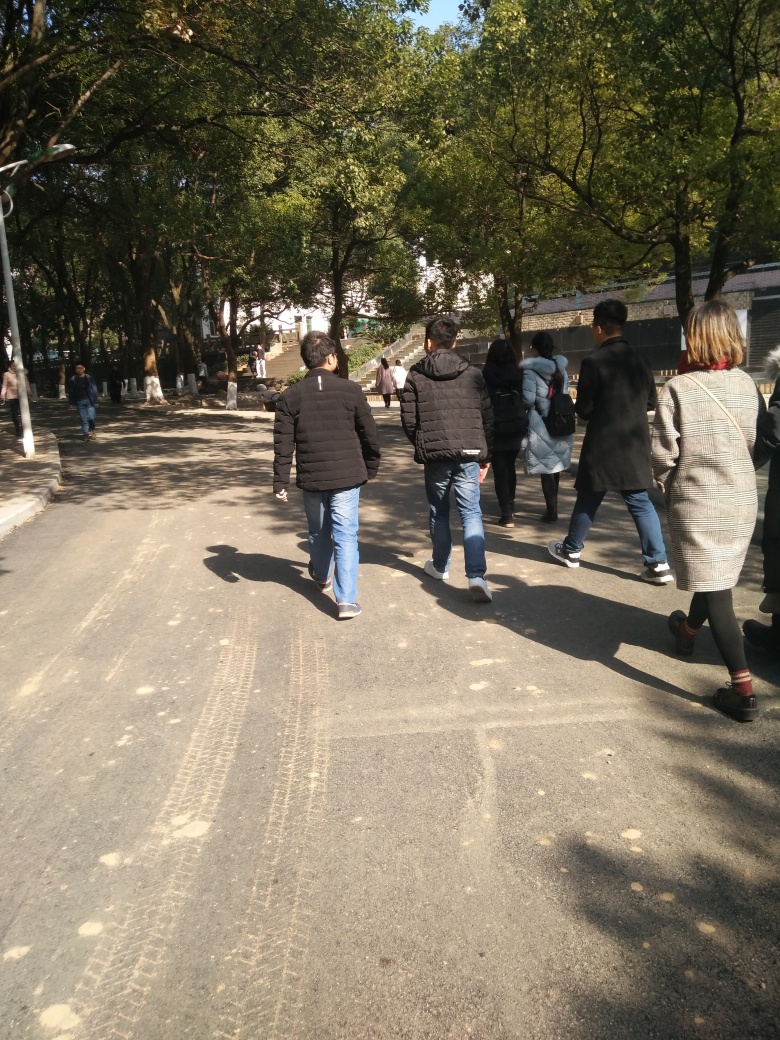What season does it appear to be in this image? The trees are full of leaves and people are dressed in light to moderate clothing, suggesting it's either spring or autumn, seasons known for mild weather. 